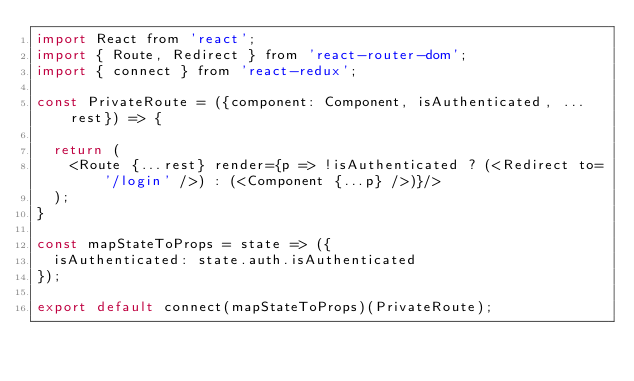<code> <loc_0><loc_0><loc_500><loc_500><_JavaScript_>import React from 'react';
import { Route, Redirect } from 'react-router-dom';
import { connect } from 'react-redux';

const PrivateRoute = ({component: Component, isAuthenticated, ...rest}) => {

  return (
    <Route {...rest} render={p => !isAuthenticated ? (<Redirect to='/login' />) : (<Component {...p} />)}/>
  );
}

const mapStateToProps = state => ({
  isAuthenticated: state.auth.isAuthenticated
});
  
export default connect(mapStateToProps)(PrivateRoute);</code> 